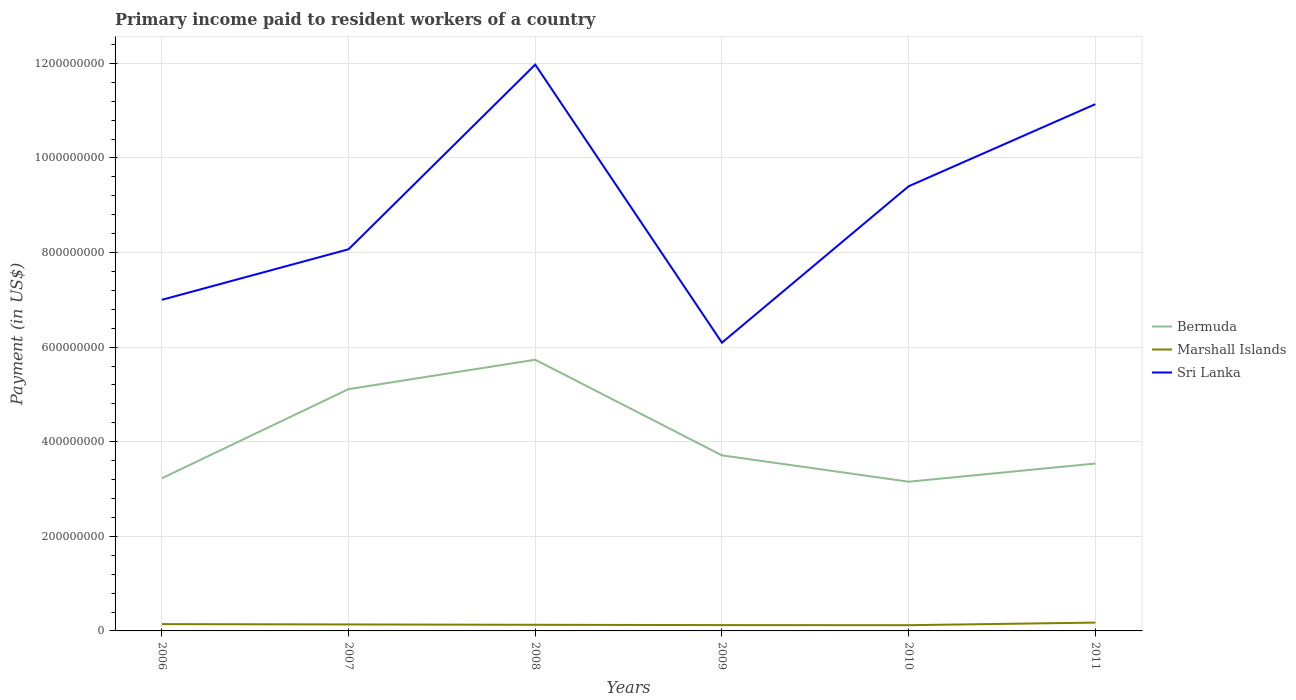How many different coloured lines are there?
Your answer should be very brief. 3. Does the line corresponding to Sri Lanka intersect with the line corresponding to Bermuda?
Offer a very short reply. No. Is the number of lines equal to the number of legend labels?
Your response must be concise. Yes. Across all years, what is the maximum amount paid to workers in Bermuda?
Provide a short and direct response. 3.15e+08. In which year was the amount paid to workers in Marshall Islands maximum?
Keep it short and to the point. 2010. What is the total amount paid to workers in Bermuda in the graph?
Offer a terse response. 1.72e+07. What is the difference between the highest and the second highest amount paid to workers in Marshall Islands?
Provide a short and direct response. 5.51e+06. Is the amount paid to workers in Sri Lanka strictly greater than the amount paid to workers in Bermuda over the years?
Your response must be concise. No. What is the difference between two consecutive major ticks on the Y-axis?
Ensure brevity in your answer.  2.00e+08. Does the graph contain any zero values?
Your response must be concise. No. Does the graph contain grids?
Ensure brevity in your answer.  Yes. How are the legend labels stacked?
Your response must be concise. Vertical. What is the title of the graph?
Offer a very short reply. Primary income paid to resident workers of a country. What is the label or title of the Y-axis?
Make the answer very short. Payment (in US$). What is the Payment (in US$) of Bermuda in 2006?
Offer a terse response. 3.23e+08. What is the Payment (in US$) in Marshall Islands in 2006?
Ensure brevity in your answer.  1.44e+07. What is the Payment (in US$) in Sri Lanka in 2006?
Provide a succinct answer. 7.00e+08. What is the Payment (in US$) of Bermuda in 2007?
Provide a succinct answer. 5.11e+08. What is the Payment (in US$) in Marshall Islands in 2007?
Make the answer very short. 1.37e+07. What is the Payment (in US$) in Sri Lanka in 2007?
Your answer should be compact. 8.07e+08. What is the Payment (in US$) of Bermuda in 2008?
Offer a terse response. 5.73e+08. What is the Payment (in US$) of Marshall Islands in 2008?
Give a very brief answer. 1.29e+07. What is the Payment (in US$) in Sri Lanka in 2008?
Provide a short and direct response. 1.20e+09. What is the Payment (in US$) of Bermuda in 2009?
Give a very brief answer. 3.71e+08. What is the Payment (in US$) in Marshall Islands in 2009?
Your answer should be compact. 1.23e+07. What is the Payment (in US$) of Sri Lanka in 2009?
Make the answer very short. 6.09e+08. What is the Payment (in US$) of Bermuda in 2010?
Your answer should be compact. 3.15e+08. What is the Payment (in US$) in Marshall Islands in 2010?
Your answer should be compact. 1.21e+07. What is the Payment (in US$) of Sri Lanka in 2010?
Provide a short and direct response. 9.40e+08. What is the Payment (in US$) in Bermuda in 2011?
Give a very brief answer. 3.54e+08. What is the Payment (in US$) in Marshall Islands in 2011?
Provide a succinct answer. 1.76e+07. What is the Payment (in US$) of Sri Lanka in 2011?
Your answer should be very brief. 1.11e+09. Across all years, what is the maximum Payment (in US$) of Bermuda?
Provide a succinct answer. 5.73e+08. Across all years, what is the maximum Payment (in US$) in Marshall Islands?
Your answer should be compact. 1.76e+07. Across all years, what is the maximum Payment (in US$) of Sri Lanka?
Your response must be concise. 1.20e+09. Across all years, what is the minimum Payment (in US$) of Bermuda?
Provide a short and direct response. 3.15e+08. Across all years, what is the minimum Payment (in US$) of Marshall Islands?
Ensure brevity in your answer.  1.21e+07. Across all years, what is the minimum Payment (in US$) of Sri Lanka?
Keep it short and to the point. 6.09e+08. What is the total Payment (in US$) of Bermuda in the graph?
Offer a terse response. 2.45e+09. What is the total Payment (in US$) of Marshall Islands in the graph?
Make the answer very short. 8.31e+07. What is the total Payment (in US$) of Sri Lanka in the graph?
Your answer should be compact. 5.37e+09. What is the difference between the Payment (in US$) of Bermuda in 2006 and that in 2007?
Offer a terse response. -1.88e+08. What is the difference between the Payment (in US$) in Marshall Islands in 2006 and that in 2007?
Provide a short and direct response. 6.94e+05. What is the difference between the Payment (in US$) in Sri Lanka in 2006 and that in 2007?
Provide a short and direct response. -1.07e+08. What is the difference between the Payment (in US$) of Bermuda in 2006 and that in 2008?
Give a very brief answer. -2.51e+08. What is the difference between the Payment (in US$) in Marshall Islands in 2006 and that in 2008?
Your answer should be very brief. 1.47e+06. What is the difference between the Payment (in US$) in Sri Lanka in 2006 and that in 2008?
Ensure brevity in your answer.  -4.97e+08. What is the difference between the Payment (in US$) in Bermuda in 2006 and that in 2009?
Ensure brevity in your answer.  -4.84e+07. What is the difference between the Payment (in US$) in Marshall Islands in 2006 and that in 2009?
Keep it short and to the point. 2.08e+06. What is the difference between the Payment (in US$) of Sri Lanka in 2006 and that in 2009?
Provide a succinct answer. 9.06e+07. What is the difference between the Payment (in US$) in Bermuda in 2006 and that in 2010?
Your answer should be very brief. 7.28e+06. What is the difference between the Payment (in US$) of Marshall Islands in 2006 and that in 2010?
Your answer should be compact. 2.29e+06. What is the difference between the Payment (in US$) in Sri Lanka in 2006 and that in 2010?
Your response must be concise. -2.40e+08. What is the difference between the Payment (in US$) in Bermuda in 2006 and that in 2011?
Ensure brevity in your answer.  -3.11e+07. What is the difference between the Payment (in US$) in Marshall Islands in 2006 and that in 2011?
Your answer should be compact. -3.22e+06. What is the difference between the Payment (in US$) in Sri Lanka in 2006 and that in 2011?
Ensure brevity in your answer.  -4.14e+08. What is the difference between the Payment (in US$) in Bermuda in 2007 and that in 2008?
Provide a short and direct response. -6.21e+07. What is the difference between the Payment (in US$) of Marshall Islands in 2007 and that in 2008?
Provide a short and direct response. 7.72e+05. What is the difference between the Payment (in US$) in Sri Lanka in 2007 and that in 2008?
Your answer should be very brief. -3.90e+08. What is the difference between the Payment (in US$) in Bermuda in 2007 and that in 2009?
Offer a very short reply. 1.40e+08. What is the difference between the Payment (in US$) of Marshall Islands in 2007 and that in 2009?
Give a very brief answer. 1.39e+06. What is the difference between the Payment (in US$) in Sri Lanka in 2007 and that in 2009?
Give a very brief answer. 1.97e+08. What is the difference between the Payment (in US$) of Bermuda in 2007 and that in 2010?
Ensure brevity in your answer.  1.96e+08. What is the difference between the Payment (in US$) in Marshall Islands in 2007 and that in 2010?
Your response must be concise. 1.59e+06. What is the difference between the Payment (in US$) in Sri Lanka in 2007 and that in 2010?
Give a very brief answer. -1.33e+08. What is the difference between the Payment (in US$) in Bermuda in 2007 and that in 2011?
Keep it short and to the point. 1.57e+08. What is the difference between the Payment (in US$) of Marshall Islands in 2007 and that in 2011?
Offer a very short reply. -3.91e+06. What is the difference between the Payment (in US$) in Sri Lanka in 2007 and that in 2011?
Give a very brief answer. -3.07e+08. What is the difference between the Payment (in US$) of Bermuda in 2008 and that in 2009?
Your response must be concise. 2.02e+08. What is the difference between the Payment (in US$) of Marshall Islands in 2008 and that in 2009?
Make the answer very short. 6.16e+05. What is the difference between the Payment (in US$) in Sri Lanka in 2008 and that in 2009?
Offer a terse response. 5.88e+08. What is the difference between the Payment (in US$) of Bermuda in 2008 and that in 2010?
Offer a very short reply. 2.58e+08. What is the difference between the Payment (in US$) in Marshall Islands in 2008 and that in 2010?
Your answer should be very brief. 8.22e+05. What is the difference between the Payment (in US$) of Sri Lanka in 2008 and that in 2010?
Give a very brief answer. 2.57e+08. What is the difference between the Payment (in US$) in Bermuda in 2008 and that in 2011?
Provide a short and direct response. 2.19e+08. What is the difference between the Payment (in US$) of Marshall Islands in 2008 and that in 2011?
Keep it short and to the point. -4.69e+06. What is the difference between the Payment (in US$) in Sri Lanka in 2008 and that in 2011?
Provide a succinct answer. 8.36e+07. What is the difference between the Payment (in US$) in Bermuda in 2009 and that in 2010?
Your answer should be compact. 5.57e+07. What is the difference between the Payment (in US$) in Marshall Islands in 2009 and that in 2010?
Offer a very short reply. 2.06e+05. What is the difference between the Payment (in US$) in Sri Lanka in 2009 and that in 2010?
Your answer should be compact. -3.31e+08. What is the difference between the Payment (in US$) of Bermuda in 2009 and that in 2011?
Offer a terse response. 1.72e+07. What is the difference between the Payment (in US$) of Marshall Islands in 2009 and that in 2011?
Offer a very short reply. -5.30e+06. What is the difference between the Payment (in US$) of Sri Lanka in 2009 and that in 2011?
Provide a succinct answer. -5.04e+08. What is the difference between the Payment (in US$) of Bermuda in 2010 and that in 2011?
Offer a terse response. -3.84e+07. What is the difference between the Payment (in US$) of Marshall Islands in 2010 and that in 2011?
Keep it short and to the point. -5.51e+06. What is the difference between the Payment (in US$) of Sri Lanka in 2010 and that in 2011?
Provide a succinct answer. -1.74e+08. What is the difference between the Payment (in US$) in Bermuda in 2006 and the Payment (in US$) in Marshall Islands in 2007?
Ensure brevity in your answer.  3.09e+08. What is the difference between the Payment (in US$) of Bermuda in 2006 and the Payment (in US$) of Sri Lanka in 2007?
Ensure brevity in your answer.  -4.84e+08. What is the difference between the Payment (in US$) of Marshall Islands in 2006 and the Payment (in US$) of Sri Lanka in 2007?
Ensure brevity in your answer.  -7.92e+08. What is the difference between the Payment (in US$) in Bermuda in 2006 and the Payment (in US$) in Marshall Islands in 2008?
Offer a very short reply. 3.10e+08. What is the difference between the Payment (in US$) of Bermuda in 2006 and the Payment (in US$) of Sri Lanka in 2008?
Give a very brief answer. -8.75e+08. What is the difference between the Payment (in US$) in Marshall Islands in 2006 and the Payment (in US$) in Sri Lanka in 2008?
Your answer should be compact. -1.18e+09. What is the difference between the Payment (in US$) of Bermuda in 2006 and the Payment (in US$) of Marshall Islands in 2009?
Your response must be concise. 3.10e+08. What is the difference between the Payment (in US$) in Bermuda in 2006 and the Payment (in US$) in Sri Lanka in 2009?
Your answer should be compact. -2.87e+08. What is the difference between the Payment (in US$) in Marshall Islands in 2006 and the Payment (in US$) in Sri Lanka in 2009?
Ensure brevity in your answer.  -5.95e+08. What is the difference between the Payment (in US$) in Bermuda in 2006 and the Payment (in US$) in Marshall Islands in 2010?
Keep it short and to the point. 3.11e+08. What is the difference between the Payment (in US$) of Bermuda in 2006 and the Payment (in US$) of Sri Lanka in 2010?
Provide a succinct answer. -6.17e+08. What is the difference between the Payment (in US$) in Marshall Islands in 2006 and the Payment (in US$) in Sri Lanka in 2010?
Your answer should be compact. -9.26e+08. What is the difference between the Payment (in US$) of Bermuda in 2006 and the Payment (in US$) of Marshall Islands in 2011?
Ensure brevity in your answer.  3.05e+08. What is the difference between the Payment (in US$) in Bermuda in 2006 and the Payment (in US$) in Sri Lanka in 2011?
Provide a short and direct response. -7.91e+08. What is the difference between the Payment (in US$) in Marshall Islands in 2006 and the Payment (in US$) in Sri Lanka in 2011?
Make the answer very short. -1.10e+09. What is the difference between the Payment (in US$) of Bermuda in 2007 and the Payment (in US$) of Marshall Islands in 2008?
Give a very brief answer. 4.98e+08. What is the difference between the Payment (in US$) in Bermuda in 2007 and the Payment (in US$) in Sri Lanka in 2008?
Your answer should be very brief. -6.86e+08. What is the difference between the Payment (in US$) of Marshall Islands in 2007 and the Payment (in US$) of Sri Lanka in 2008?
Your answer should be compact. -1.18e+09. What is the difference between the Payment (in US$) in Bermuda in 2007 and the Payment (in US$) in Marshall Islands in 2009?
Your answer should be compact. 4.99e+08. What is the difference between the Payment (in US$) of Bermuda in 2007 and the Payment (in US$) of Sri Lanka in 2009?
Offer a terse response. -9.82e+07. What is the difference between the Payment (in US$) in Marshall Islands in 2007 and the Payment (in US$) in Sri Lanka in 2009?
Provide a short and direct response. -5.96e+08. What is the difference between the Payment (in US$) in Bermuda in 2007 and the Payment (in US$) in Marshall Islands in 2010?
Your answer should be compact. 4.99e+08. What is the difference between the Payment (in US$) in Bermuda in 2007 and the Payment (in US$) in Sri Lanka in 2010?
Keep it short and to the point. -4.29e+08. What is the difference between the Payment (in US$) of Marshall Islands in 2007 and the Payment (in US$) of Sri Lanka in 2010?
Give a very brief answer. -9.26e+08. What is the difference between the Payment (in US$) of Bermuda in 2007 and the Payment (in US$) of Marshall Islands in 2011?
Provide a short and direct response. 4.94e+08. What is the difference between the Payment (in US$) of Bermuda in 2007 and the Payment (in US$) of Sri Lanka in 2011?
Make the answer very short. -6.02e+08. What is the difference between the Payment (in US$) of Marshall Islands in 2007 and the Payment (in US$) of Sri Lanka in 2011?
Give a very brief answer. -1.10e+09. What is the difference between the Payment (in US$) of Bermuda in 2008 and the Payment (in US$) of Marshall Islands in 2009?
Your response must be concise. 5.61e+08. What is the difference between the Payment (in US$) in Bermuda in 2008 and the Payment (in US$) in Sri Lanka in 2009?
Offer a terse response. -3.61e+07. What is the difference between the Payment (in US$) in Marshall Islands in 2008 and the Payment (in US$) in Sri Lanka in 2009?
Offer a very short reply. -5.96e+08. What is the difference between the Payment (in US$) in Bermuda in 2008 and the Payment (in US$) in Marshall Islands in 2010?
Make the answer very short. 5.61e+08. What is the difference between the Payment (in US$) in Bermuda in 2008 and the Payment (in US$) in Sri Lanka in 2010?
Make the answer very short. -3.67e+08. What is the difference between the Payment (in US$) in Marshall Islands in 2008 and the Payment (in US$) in Sri Lanka in 2010?
Provide a short and direct response. -9.27e+08. What is the difference between the Payment (in US$) in Bermuda in 2008 and the Payment (in US$) in Marshall Islands in 2011?
Make the answer very short. 5.56e+08. What is the difference between the Payment (in US$) in Bermuda in 2008 and the Payment (in US$) in Sri Lanka in 2011?
Your answer should be compact. -5.40e+08. What is the difference between the Payment (in US$) of Marshall Islands in 2008 and the Payment (in US$) of Sri Lanka in 2011?
Your response must be concise. -1.10e+09. What is the difference between the Payment (in US$) of Bermuda in 2009 and the Payment (in US$) of Marshall Islands in 2010?
Your answer should be compact. 3.59e+08. What is the difference between the Payment (in US$) of Bermuda in 2009 and the Payment (in US$) of Sri Lanka in 2010?
Ensure brevity in your answer.  -5.69e+08. What is the difference between the Payment (in US$) of Marshall Islands in 2009 and the Payment (in US$) of Sri Lanka in 2010?
Keep it short and to the point. -9.28e+08. What is the difference between the Payment (in US$) in Bermuda in 2009 and the Payment (in US$) in Marshall Islands in 2011?
Offer a terse response. 3.54e+08. What is the difference between the Payment (in US$) in Bermuda in 2009 and the Payment (in US$) in Sri Lanka in 2011?
Ensure brevity in your answer.  -7.43e+08. What is the difference between the Payment (in US$) of Marshall Islands in 2009 and the Payment (in US$) of Sri Lanka in 2011?
Make the answer very short. -1.10e+09. What is the difference between the Payment (in US$) in Bermuda in 2010 and the Payment (in US$) in Marshall Islands in 2011?
Make the answer very short. 2.98e+08. What is the difference between the Payment (in US$) of Bermuda in 2010 and the Payment (in US$) of Sri Lanka in 2011?
Your response must be concise. -7.98e+08. What is the difference between the Payment (in US$) in Marshall Islands in 2010 and the Payment (in US$) in Sri Lanka in 2011?
Ensure brevity in your answer.  -1.10e+09. What is the average Payment (in US$) of Bermuda per year?
Ensure brevity in your answer.  4.08e+08. What is the average Payment (in US$) in Marshall Islands per year?
Give a very brief answer. 1.38e+07. What is the average Payment (in US$) in Sri Lanka per year?
Your answer should be very brief. 8.95e+08. In the year 2006, what is the difference between the Payment (in US$) of Bermuda and Payment (in US$) of Marshall Islands?
Give a very brief answer. 3.08e+08. In the year 2006, what is the difference between the Payment (in US$) of Bermuda and Payment (in US$) of Sri Lanka?
Ensure brevity in your answer.  -3.77e+08. In the year 2006, what is the difference between the Payment (in US$) of Marshall Islands and Payment (in US$) of Sri Lanka?
Your answer should be very brief. -6.86e+08. In the year 2007, what is the difference between the Payment (in US$) in Bermuda and Payment (in US$) in Marshall Islands?
Provide a succinct answer. 4.98e+08. In the year 2007, what is the difference between the Payment (in US$) in Bermuda and Payment (in US$) in Sri Lanka?
Ensure brevity in your answer.  -2.96e+08. In the year 2007, what is the difference between the Payment (in US$) in Marshall Islands and Payment (in US$) in Sri Lanka?
Give a very brief answer. -7.93e+08. In the year 2008, what is the difference between the Payment (in US$) in Bermuda and Payment (in US$) in Marshall Islands?
Give a very brief answer. 5.60e+08. In the year 2008, what is the difference between the Payment (in US$) in Bermuda and Payment (in US$) in Sri Lanka?
Provide a short and direct response. -6.24e+08. In the year 2008, what is the difference between the Payment (in US$) in Marshall Islands and Payment (in US$) in Sri Lanka?
Your answer should be very brief. -1.18e+09. In the year 2009, what is the difference between the Payment (in US$) of Bermuda and Payment (in US$) of Marshall Islands?
Keep it short and to the point. 3.59e+08. In the year 2009, what is the difference between the Payment (in US$) in Bermuda and Payment (in US$) in Sri Lanka?
Ensure brevity in your answer.  -2.38e+08. In the year 2009, what is the difference between the Payment (in US$) in Marshall Islands and Payment (in US$) in Sri Lanka?
Your answer should be very brief. -5.97e+08. In the year 2010, what is the difference between the Payment (in US$) in Bermuda and Payment (in US$) in Marshall Islands?
Offer a terse response. 3.03e+08. In the year 2010, what is the difference between the Payment (in US$) of Bermuda and Payment (in US$) of Sri Lanka?
Your response must be concise. -6.25e+08. In the year 2010, what is the difference between the Payment (in US$) of Marshall Islands and Payment (in US$) of Sri Lanka?
Ensure brevity in your answer.  -9.28e+08. In the year 2011, what is the difference between the Payment (in US$) in Bermuda and Payment (in US$) in Marshall Islands?
Ensure brevity in your answer.  3.36e+08. In the year 2011, what is the difference between the Payment (in US$) in Bermuda and Payment (in US$) in Sri Lanka?
Your response must be concise. -7.60e+08. In the year 2011, what is the difference between the Payment (in US$) of Marshall Islands and Payment (in US$) of Sri Lanka?
Keep it short and to the point. -1.10e+09. What is the ratio of the Payment (in US$) of Bermuda in 2006 to that in 2007?
Give a very brief answer. 0.63. What is the ratio of the Payment (in US$) of Marshall Islands in 2006 to that in 2007?
Keep it short and to the point. 1.05. What is the ratio of the Payment (in US$) of Sri Lanka in 2006 to that in 2007?
Keep it short and to the point. 0.87. What is the ratio of the Payment (in US$) in Bermuda in 2006 to that in 2008?
Your response must be concise. 0.56. What is the ratio of the Payment (in US$) of Marshall Islands in 2006 to that in 2008?
Give a very brief answer. 1.11. What is the ratio of the Payment (in US$) of Sri Lanka in 2006 to that in 2008?
Ensure brevity in your answer.  0.58. What is the ratio of the Payment (in US$) in Bermuda in 2006 to that in 2009?
Your answer should be compact. 0.87. What is the ratio of the Payment (in US$) in Marshall Islands in 2006 to that in 2009?
Your response must be concise. 1.17. What is the ratio of the Payment (in US$) in Sri Lanka in 2006 to that in 2009?
Offer a very short reply. 1.15. What is the ratio of the Payment (in US$) of Bermuda in 2006 to that in 2010?
Your response must be concise. 1.02. What is the ratio of the Payment (in US$) of Marshall Islands in 2006 to that in 2010?
Your answer should be very brief. 1.19. What is the ratio of the Payment (in US$) of Sri Lanka in 2006 to that in 2010?
Provide a short and direct response. 0.74. What is the ratio of the Payment (in US$) of Bermuda in 2006 to that in 2011?
Give a very brief answer. 0.91. What is the ratio of the Payment (in US$) in Marshall Islands in 2006 to that in 2011?
Your response must be concise. 0.82. What is the ratio of the Payment (in US$) of Sri Lanka in 2006 to that in 2011?
Your answer should be very brief. 0.63. What is the ratio of the Payment (in US$) in Bermuda in 2007 to that in 2008?
Make the answer very short. 0.89. What is the ratio of the Payment (in US$) in Marshall Islands in 2007 to that in 2008?
Offer a terse response. 1.06. What is the ratio of the Payment (in US$) in Sri Lanka in 2007 to that in 2008?
Give a very brief answer. 0.67. What is the ratio of the Payment (in US$) in Bermuda in 2007 to that in 2009?
Your answer should be compact. 1.38. What is the ratio of the Payment (in US$) of Marshall Islands in 2007 to that in 2009?
Your response must be concise. 1.11. What is the ratio of the Payment (in US$) in Sri Lanka in 2007 to that in 2009?
Make the answer very short. 1.32. What is the ratio of the Payment (in US$) in Bermuda in 2007 to that in 2010?
Offer a very short reply. 1.62. What is the ratio of the Payment (in US$) of Marshall Islands in 2007 to that in 2010?
Offer a very short reply. 1.13. What is the ratio of the Payment (in US$) in Sri Lanka in 2007 to that in 2010?
Your answer should be very brief. 0.86. What is the ratio of the Payment (in US$) in Bermuda in 2007 to that in 2011?
Ensure brevity in your answer.  1.44. What is the ratio of the Payment (in US$) in Marshall Islands in 2007 to that in 2011?
Your answer should be very brief. 0.78. What is the ratio of the Payment (in US$) of Sri Lanka in 2007 to that in 2011?
Your answer should be compact. 0.72. What is the ratio of the Payment (in US$) of Bermuda in 2008 to that in 2009?
Your answer should be compact. 1.54. What is the ratio of the Payment (in US$) in Sri Lanka in 2008 to that in 2009?
Keep it short and to the point. 1.96. What is the ratio of the Payment (in US$) of Bermuda in 2008 to that in 2010?
Your answer should be compact. 1.82. What is the ratio of the Payment (in US$) of Marshall Islands in 2008 to that in 2010?
Your response must be concise. 1.07. What is the ratio of the Payment (in US$) in Sri Lanka in 2008 to that in 2010?
Your response must be concise. 1.27. What is the ratio of the Payment (in US$) in Bermuda in 2008 to that in 2011?
Make the answer very short. 1.62. What is the ratio of the Payment (in US$) of Marshall Islands in 2008 to that in 2011?
Offer a terse response. 0.73. What is the ratio of the Payment (in US$) in Sri Lanka in 2008 to that in 2011?
Offer a very short reply. 1.08. What is the ratio of the Payment (in US$) in Bermuda in 2009 to that in 2010?
Offer a very short reply. 1.18. What is the ratio of the Payment (in US$) of Marshall Islands in 2009 to that in 2010?
Offer a terse response. 1.02. What is the ratio of the Payment (in US$) in Sri Lanka in 2009 to that in 2010?
Your response must be concise. 0.65. What is the ratio of the Payment (in US$) of Bermuda in 2009 to that in 2011?
Make the answer very short. 1.05. What is the ratio of the Payment (in US$) of Marshall Islands in 2009 to that in 2011?
Give a very brief answer. 0.7. What is the ratio of the Payment (in US$) in Sri Lanka in 2009 to that in 2011?
Your answer should be very brief. 0.55. What is the ratio of the Payment (in US$) of Bermuda in 2010 to that in 2011?
Your answer should be compact. 0.89. What is the ratio of the Payment (in US$) of Marshall Islands in 2010 to that in 2011?
Provide a succinct answer. 0.69. What is the ratio of the Payment (in US$) of Sri Lanka in 2010 to that in 2011?
Give a very brief answer. 0.84. What is the difference between the highest and the second highest Payment (in US$) in Bermuda?
Ensure brevity in your answer.  6.21e+07. What is the difference between the highest and the second highest Payment (in US$) of Marshall Islands?
Offer a very short reply. 3.22e+06. What is the difference between the highest and the second highest Payment (in US$) in Sri Lanka?
Your response must be concise. 8.36e+07. What is the difference between the highest and the lowest Payment (in US$) in Bermuda?
Offer a terse response. 2.58e+08. What is the difference between the highest and the lowest Payment (in US$) of Marshall Islands?
Keep it short and to the point. 5.51e+06. What is the difference between the highest and the lowest Payment (in US$) of Sri Lanka?
Your response must be concise. 5.88e+08. 